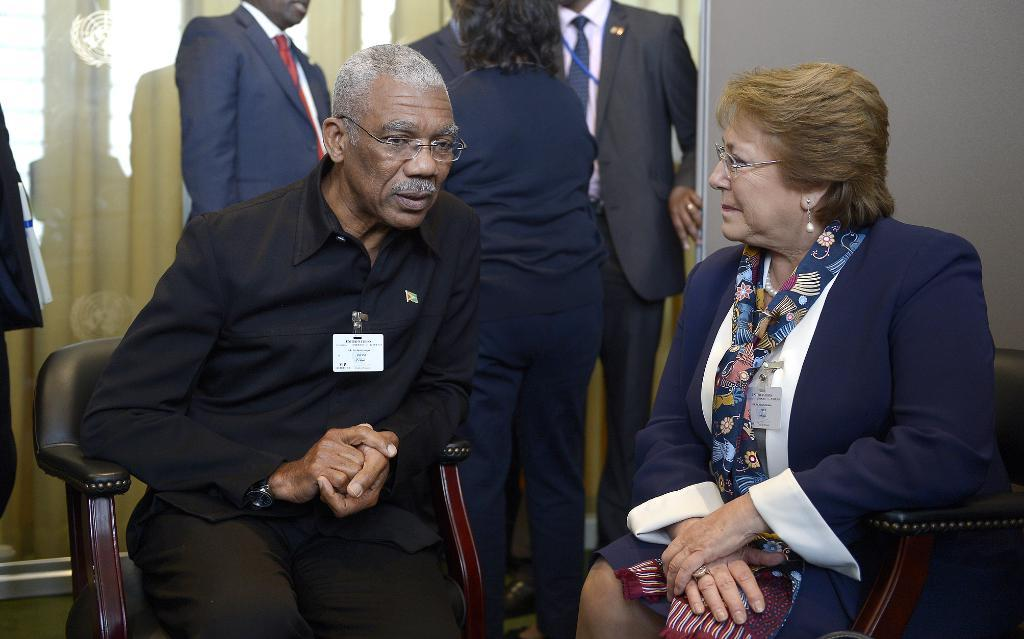What are the people in the image wearing on their faces? The men in the image are wearing spectacles. What is the woman in the image wearing on her head? The woman is wearing a scarf. What are the men and woman sitting on in the image? They are sitting on chairs. Can you describe the people in the background of the image? There are people standing in the background of the image. How much property does the woman own in the image? There is no information about property ownership in the image. What type of school is depicted in the image? There is no school present in the image. 